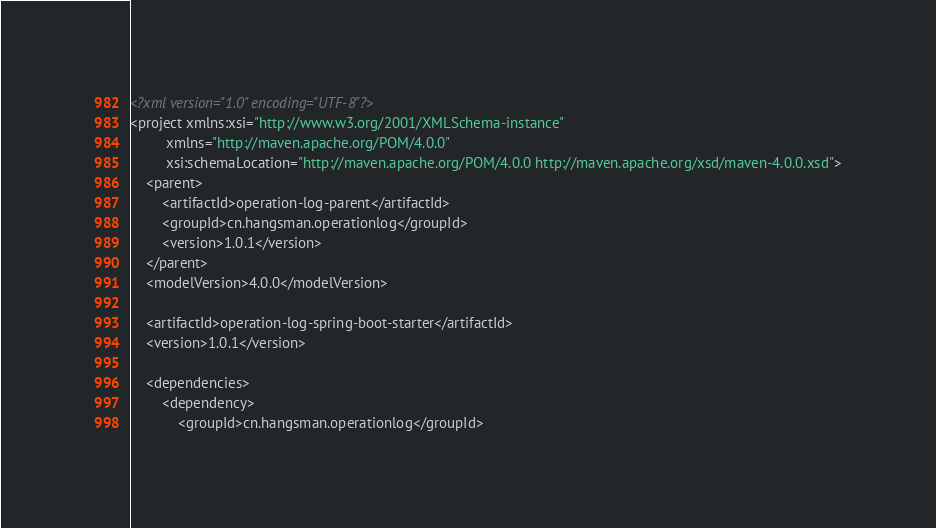Convert code to text. <code><loc_0><loc_0><loc_500><loc_500><_XML_><?xml version="1.0" encoding="UTF-8"?>
<project xmlns:xsi="http://www.w3.org/2001/XMLSchema-instance"
         xmlns="http://maven.apache.org/POM/4.0.0"
         xsi:schemaLocation="http://maven.apache.org/POM/4.0.0 http://maven.apache.org/xsd/maven-4.0.0.xsd">
    <parent>
        <artifactId>operation-log-parent</artifactId>
        <groupId>cn.hangsman.operationlog</groupId>
        <version>1.0.1</version>
    </parent>
    <modelVersion>4.0.0</modelVersion>

    <artifactId>operation-log-spring-boot-starter</artifactId>
    <version>1.0.1</version>

    <dependencies>
        <dependency>
            <groupId>cn.hangsman.operationlog</groupId></code> 